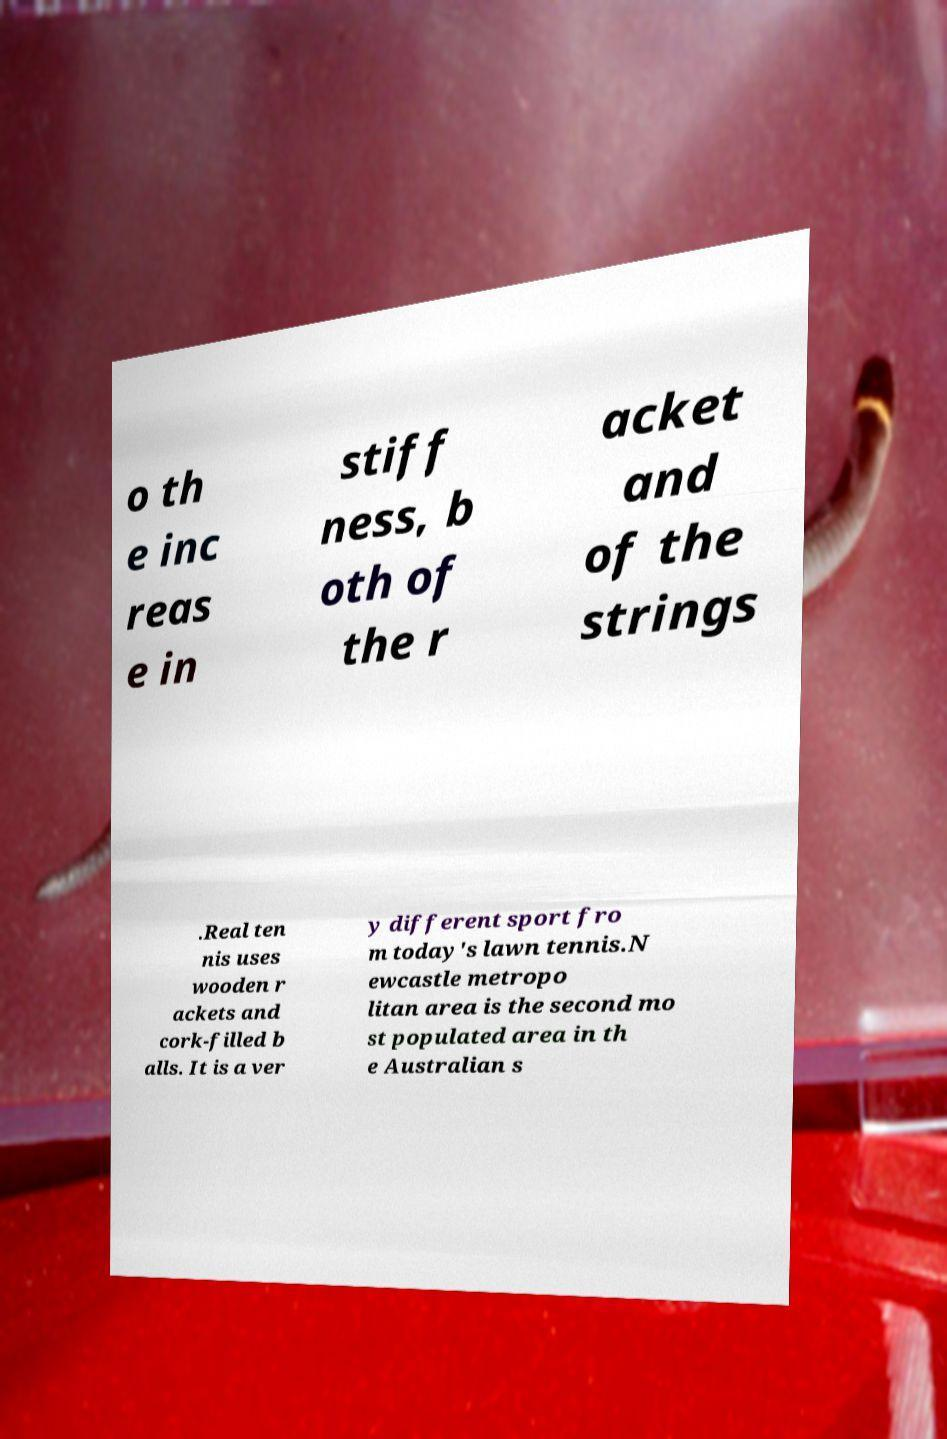Could you assist in decoding the text presented in this image and type it out clearly? o th e inc reas e in stiff ness, b oth of the r acket and of the strings .Real ten nis uses wooden r ackets and cork-filled b alls. It is a ver y different sport fro m today's lawn tennis.N ewcastle metropo litan area is the second mo st populated area in th e Australian s 